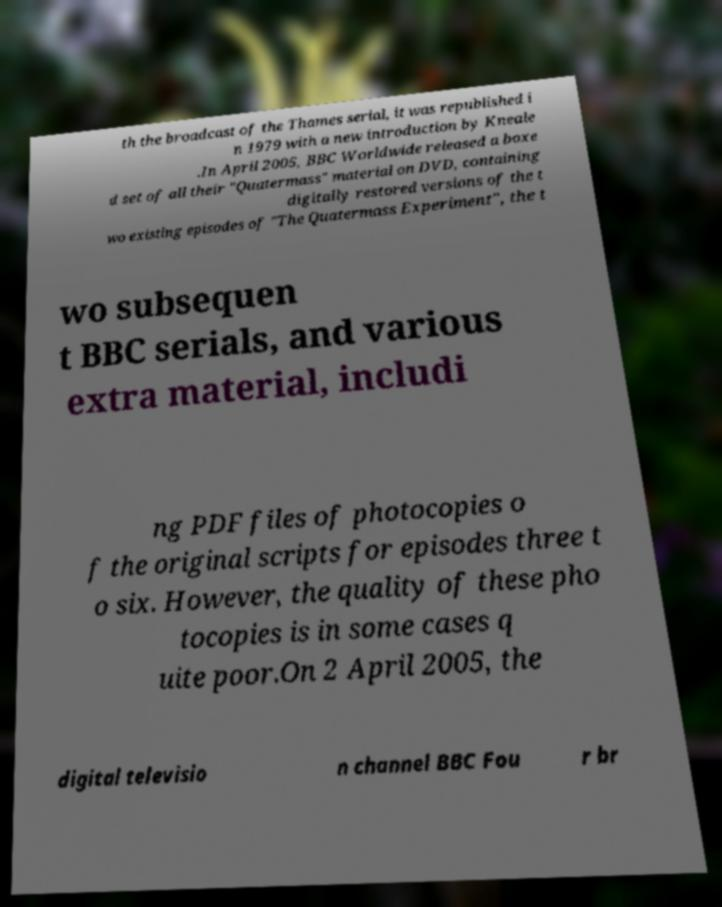There's text embedded in this image that I need extracted. Can you transcribe it verbatim? th the broadcast of the Thames serial, it was republished i n 1979 with a new introduction by Kneale .In April 2005, BBC Worldwide released a boxe d set of all their "Quatermass" material on DVD, containing digitally restored versions of the t wo existing episodes of "The Quatermass Experiment", the t wo subsequen t BBC serials, and various extra material, includi ng PDF files of photocopies o f the original scripts for episodes three t o six. However, the quality of these pho tocopies is in some cases q uite poor.On 2 April 2005, the digital televisio n channel BBC Fou r br 